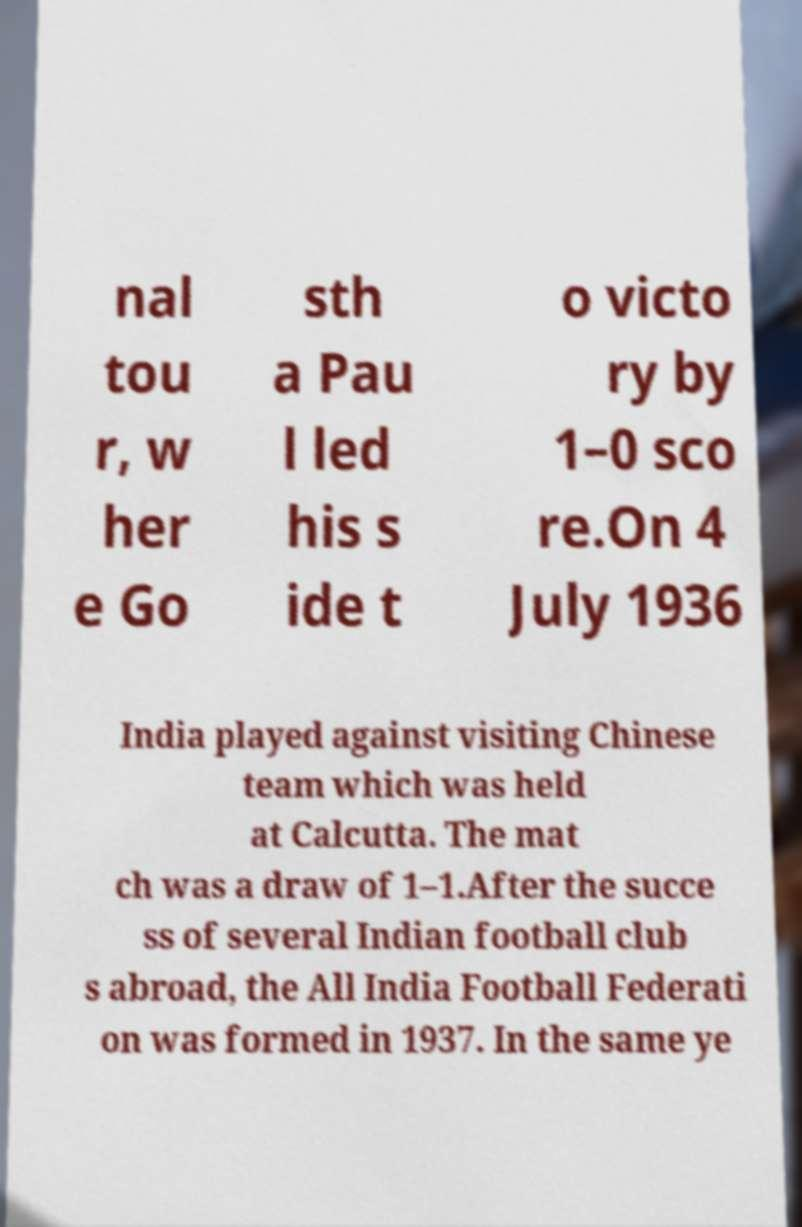Please read and relay the text visible in this image. What does it say? nal tou r, w her e Go sth a Pau l led his s ide t o victo ry by 1–0 sco re.On 4 July 1936 India played against visiting Chinese team which was held at Calcutta. The mat ch was a draw of 1–1.After the succe ss of several Indian football club s abroad, the All India Football Federati on was formed in 1937. In the same ye 